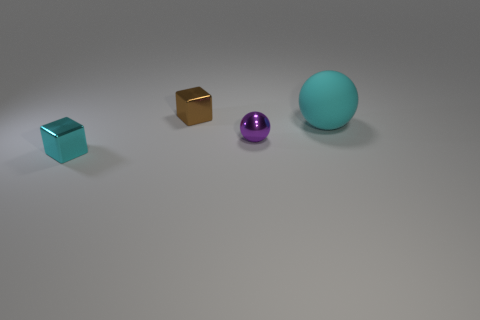Add 2 objects. How many objects exist? 6 Add 2 tiny purple balls. How many tiny purple balls are left? 3 Add 3 large gray metallic cylinders. How many large gray metallic cylinders exist? 3 Subtract 0 green spheres. How many objects are left? 4 Subtract 2 spheres. How many spheres are left? 0 Subtract all gray spheres. Subtract all red blocks. How many spheres are left? 2 Subtract all green spheres. How many brown blocks are left? 1 Subtract all small brown cubes. Subtract all big purple rubber objects. How many objects are left? 3 